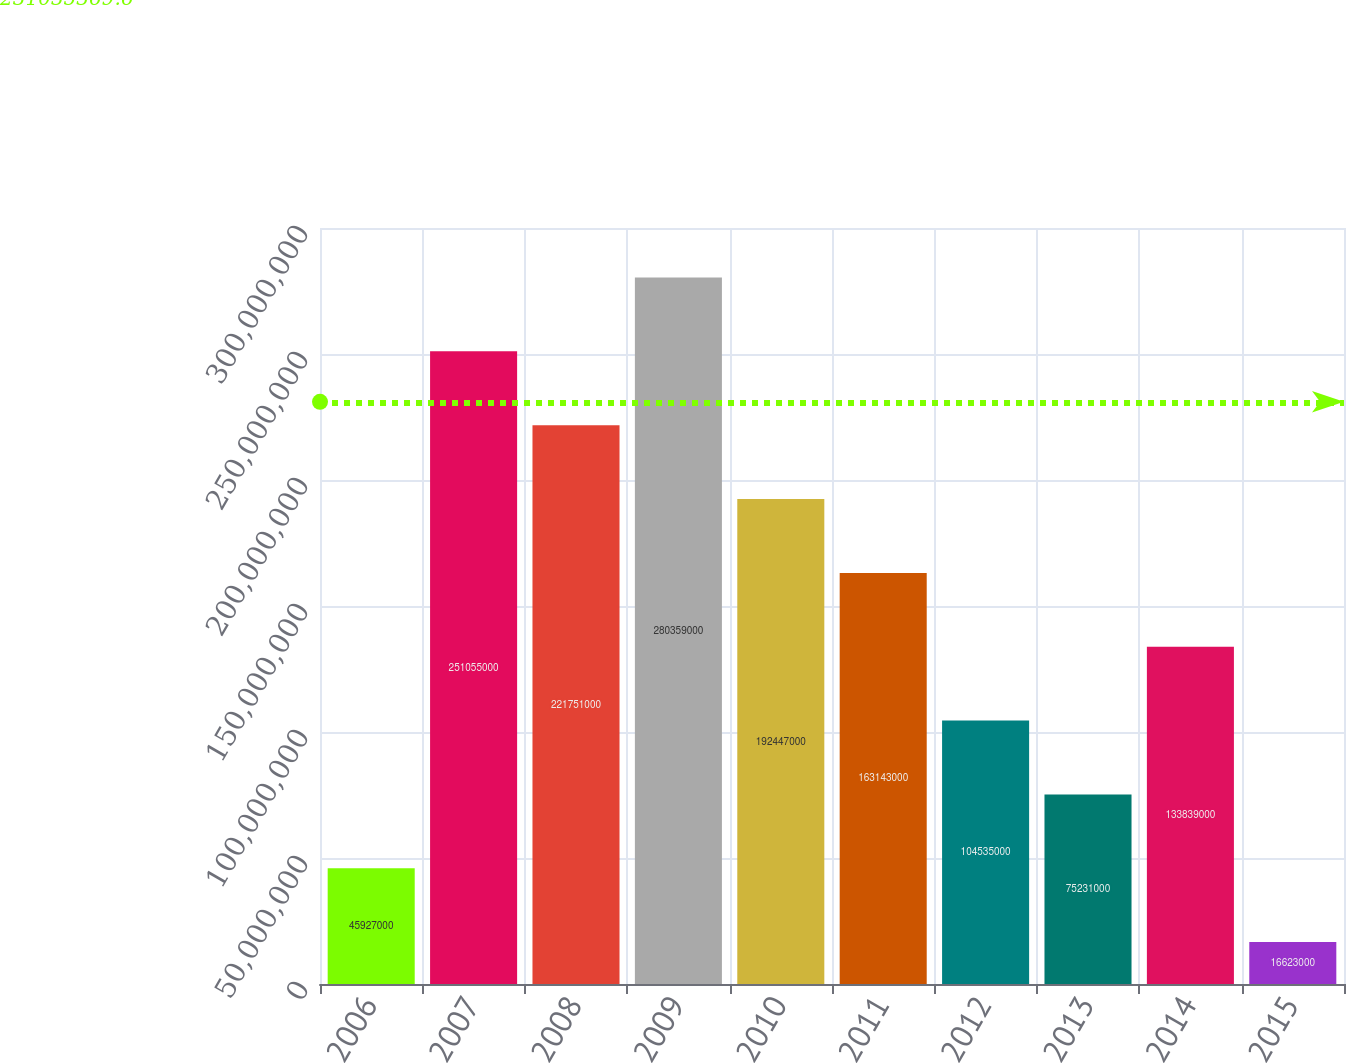Convert chart to OTSL. <chart><loc_0><loc_0><loc_500><loc_500><bar_chart><fcel>2006<fcel>2007<fcel>2008<fcel>2009<fcel>2010<fcel>2011<fcel>2012<fcel>2013<fcel>2014<fcel>2015<nl><fcel>4.5927e+07<fcel>2.51055e+08<fcel>2.21751e+08<fcel>2.80359e+08<fcel>1.92447e+08<fcel>1.63143e+08<fcel>1.04535e+08<fcel>7.5231e+07<fcel>1.33839e+08<fcel>1.6623e+07<nl></chart> 